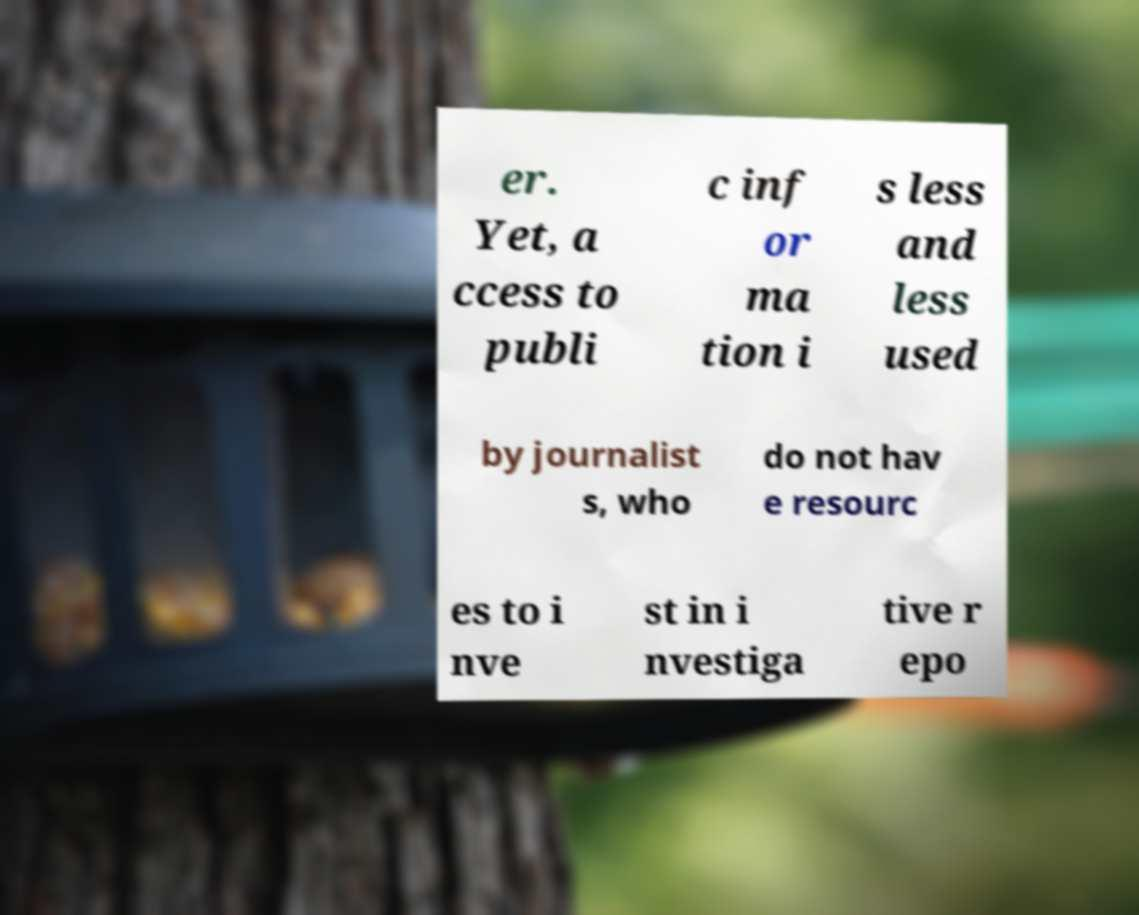Could you assist in decoding the text presented in this image and type it out clearly? er. Yet, a ccess to publi c inf or ma tion i s less and less used by journalist s, who do not hav e resourc es to i nve st in i nvestiga tive r epo 